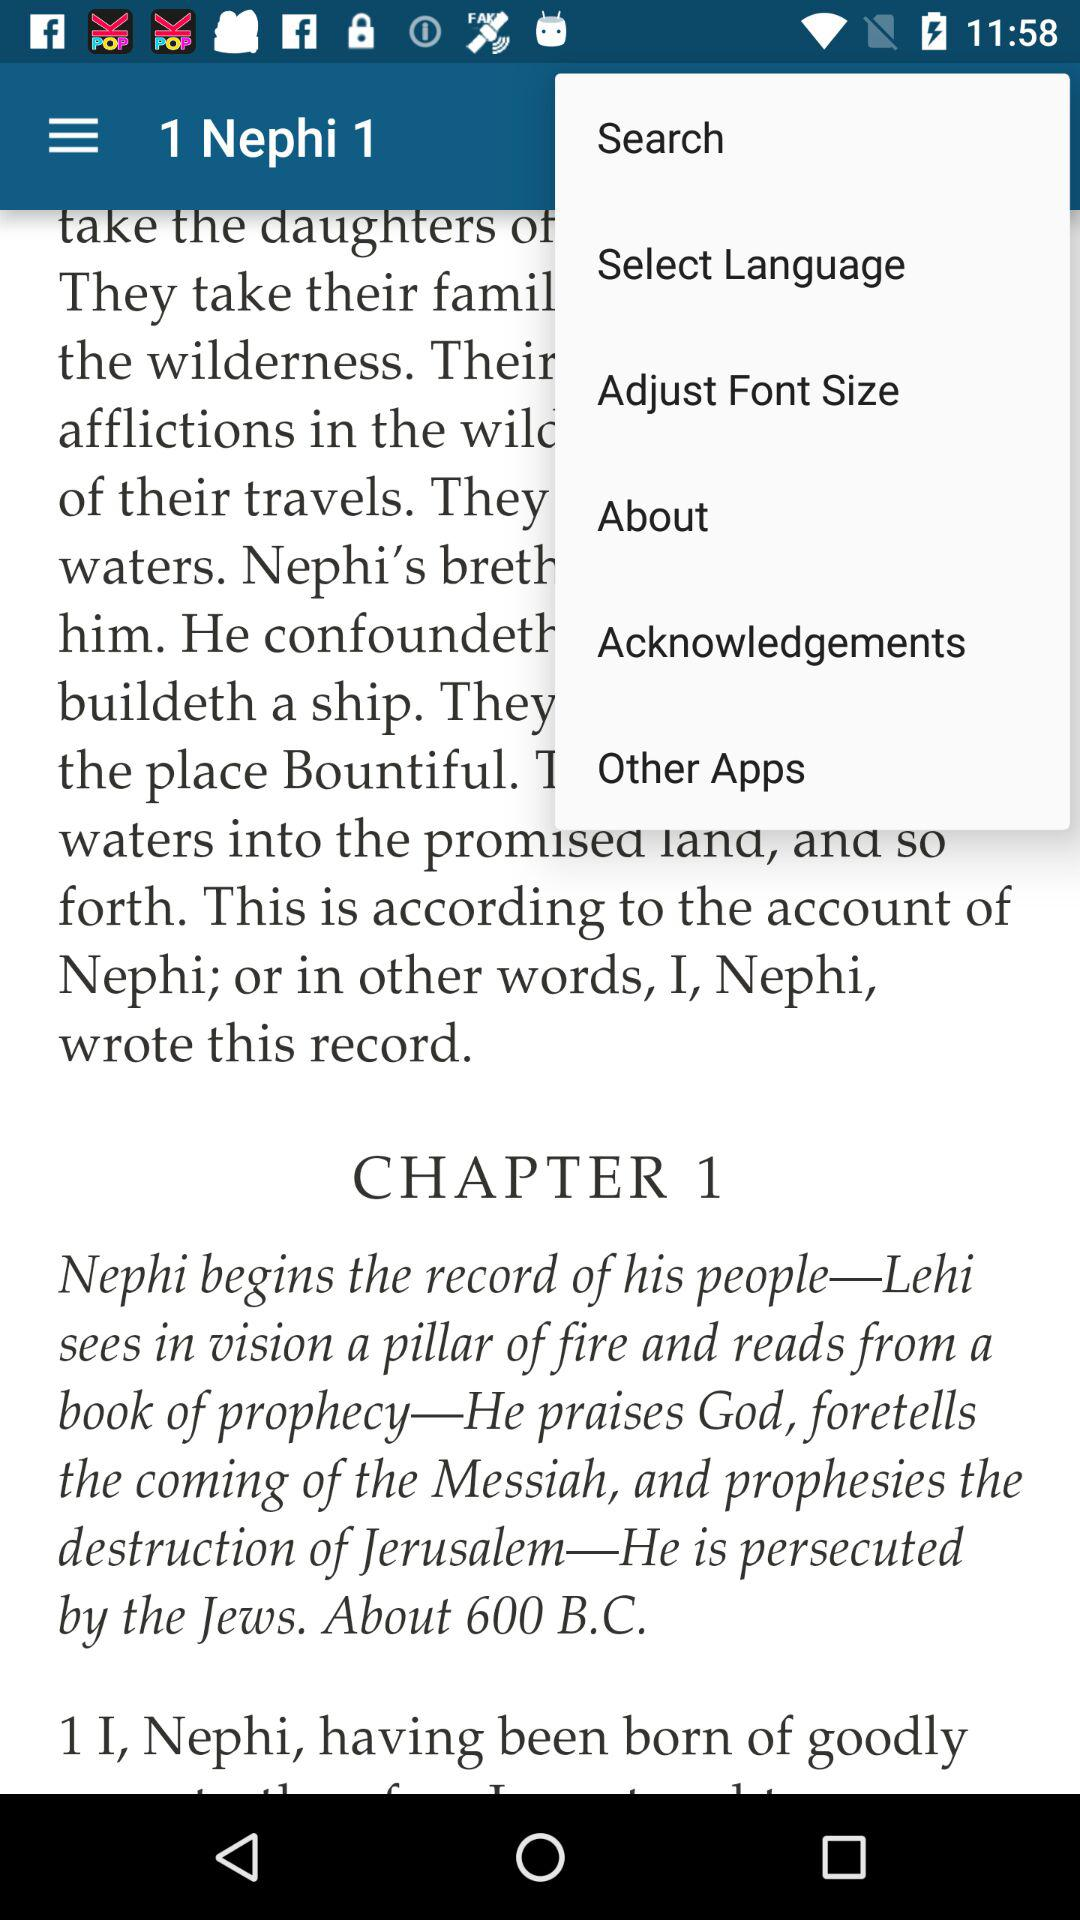Which century are you talking about?
When the provided information is insufficient, respond with <no answer>. <no answer> 